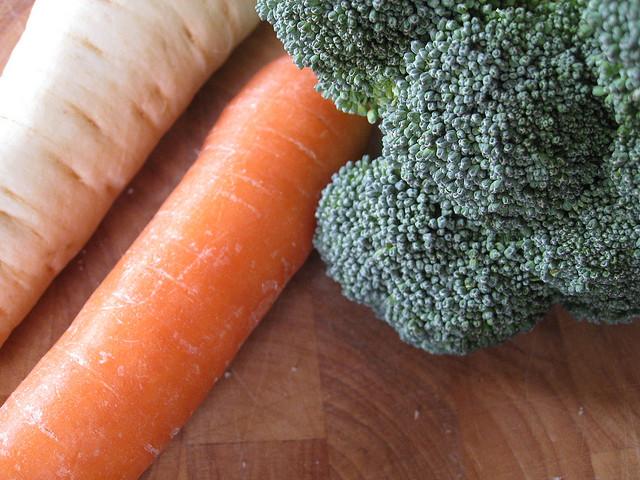What kind of cutting board are they on?
Be succinct. Wood. Are there any fruits in this picture?
Be succinct. No. Are these healthy foods?
Concise answer only. Yes. 